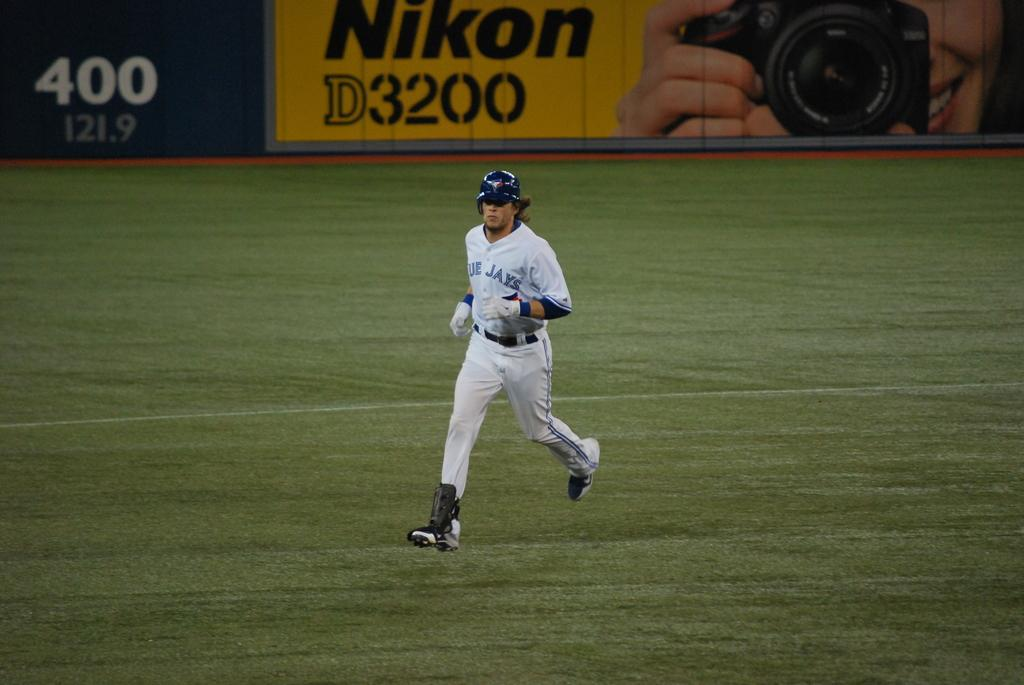What is the main action of the person in the image? There is a person running in the image. What type of surface is the person running on? The person is running on grass. What can be seen at the top of the image? There is a banner at the top of the image. What type of lunch is the person eating while running in the image? There is no lunch present in the image; the person is running and not eating. Can you tell me how many docks are visible in the image? There are no docks present in the image. 